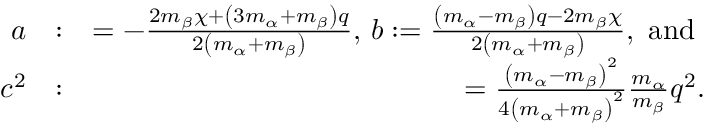Convert formula to latex. <formula><loc_0><loc_0><loc_500><loc_500>\begin{array} { r l r } { a } & { \colon } & { = - \frac { 2 m _ { \beta } \chi + \left ( 3 m _ { \alpha } + m _ { \beta } \right ) q } { 2 \left ( m _ { \alpha } + m _ { \beta } \right ) } , b \colon = \frac { \left ( m _ { \alpha } - m _ { \beta } \right ) q - 2 m _ { \beta } \chi } { 2 \left ( m _ { \alpha } + m _ { \beta } \right ) } , a n d } \\ { c ^ { 2 } } & { \colon } & { = \frac { \left ( m _ { \alpha } - m _ { \beta } \right ) ^ { 2 } } { 4 \left ( m _ { \alpha } + m _ { \beta } \right ) ^ { 2 } } \frac { m _ { \alpha } } { m _ { \beta } } q ^ { 2 } . } \end{array}</formula> 